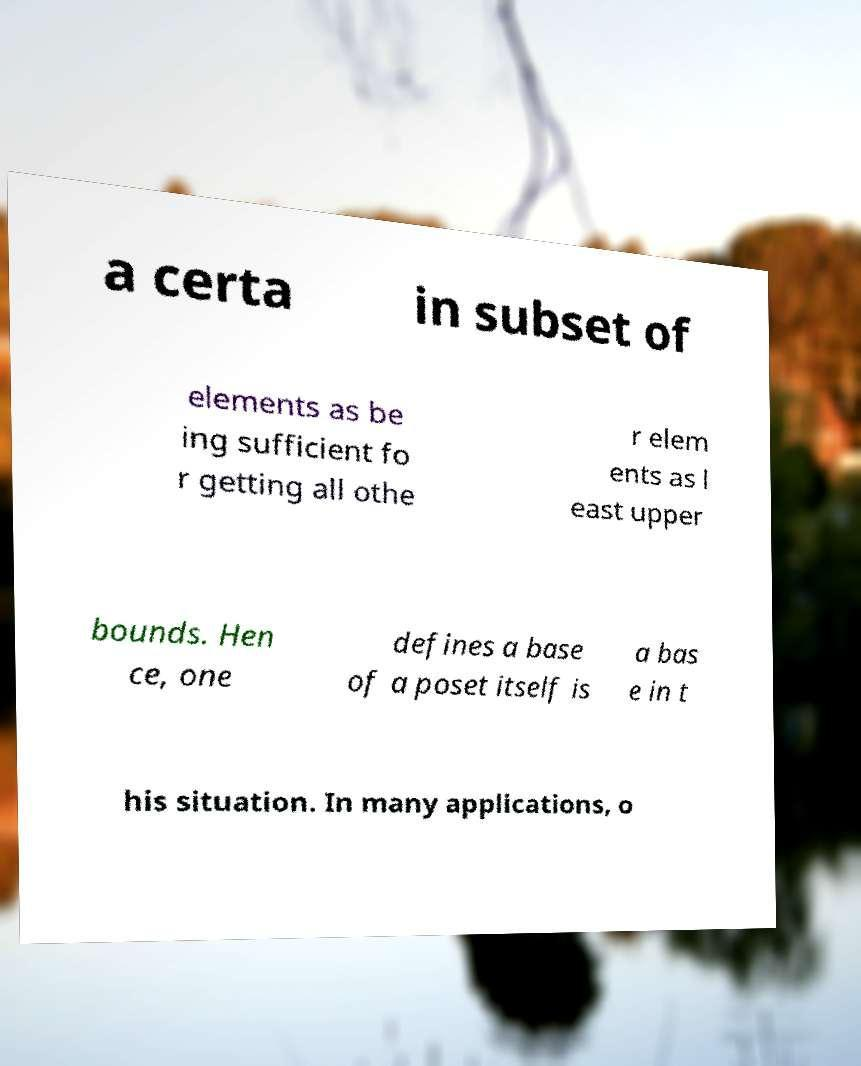Can you accurately transcribe the text from the provided image for me? a certa in subset of elements as be ing sufficient fo r getting all othe r elem ents as l east upper bounds. Hen ce, one defines a base of a poset itself is a bas e in t his situation. In many applications, o 